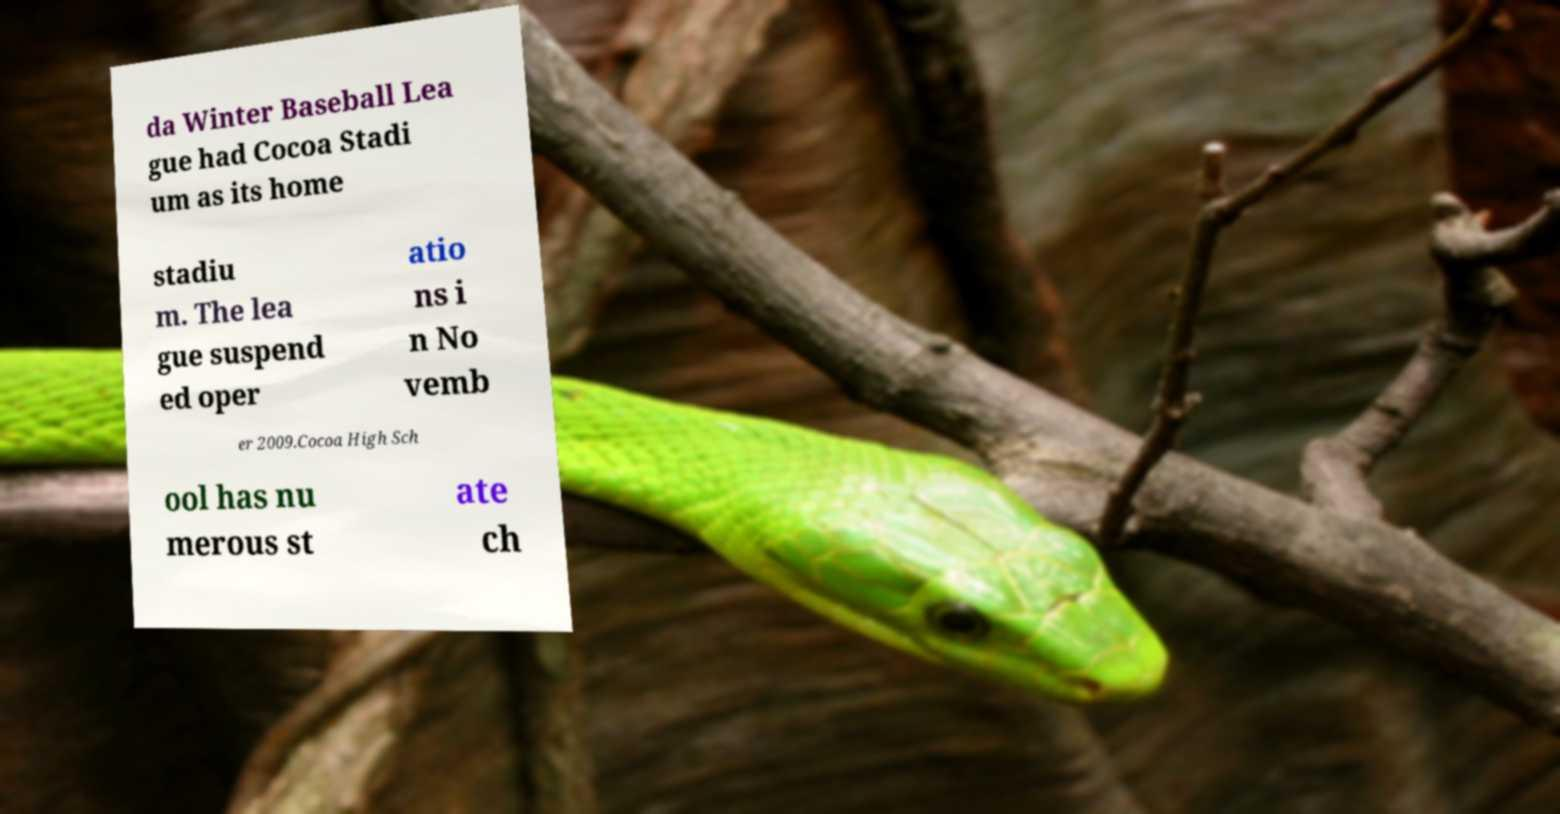Please identify and transcribe the text found in this image. da Winter Baseball Lea gue had Cocoa Stadi um as its home stadiu m. The lea gue suspend ed oper atio ns i n No vemb er 2009.Cocoa High Sch ool has nu merous st ate ch 